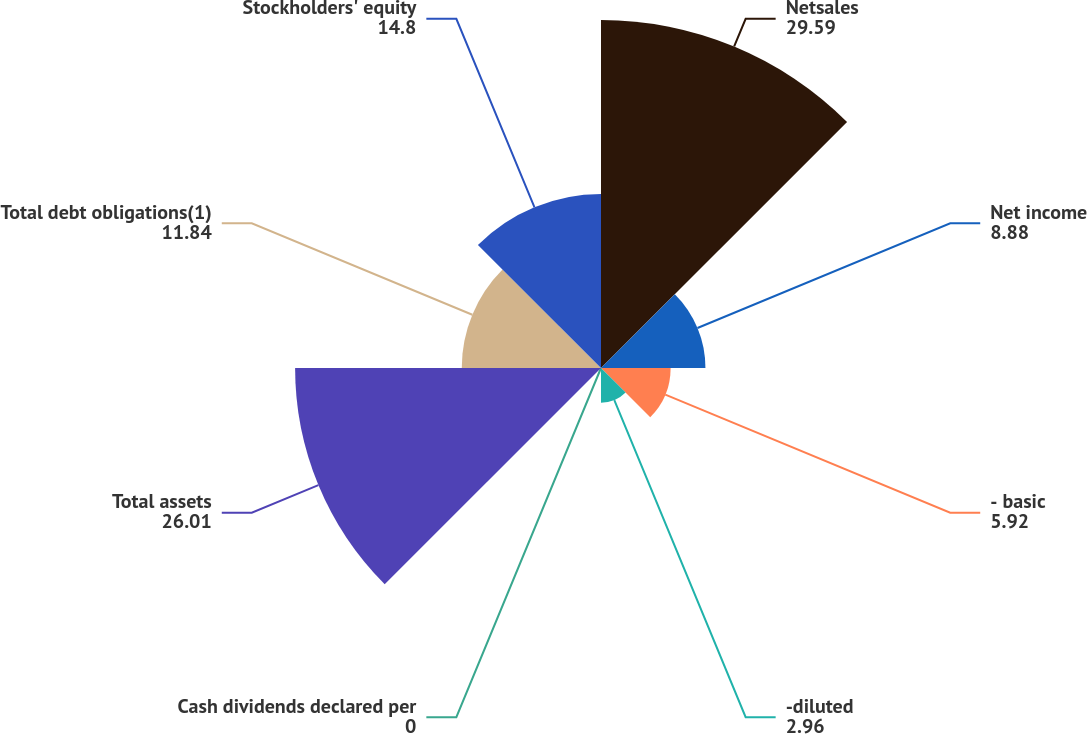<chart> <loc_0><loc_0><loc_500><loc_500><pie_chart><fcel>Netsales<fcel>Net income<fcel>- basic<fcel>-diluted<fcel>Cash dividends declared per<fcel>Total assets<fcel>Total debt obligations(1)<fcel>Stockholders' equity<nl><fcel>29.59%<fcel>8.88%<fcel>5.92%<fcel>2.96%<fcel>0.0%<fcel>26.01%<fcel>11.84%<fcel>14.8%<nl></chart> 